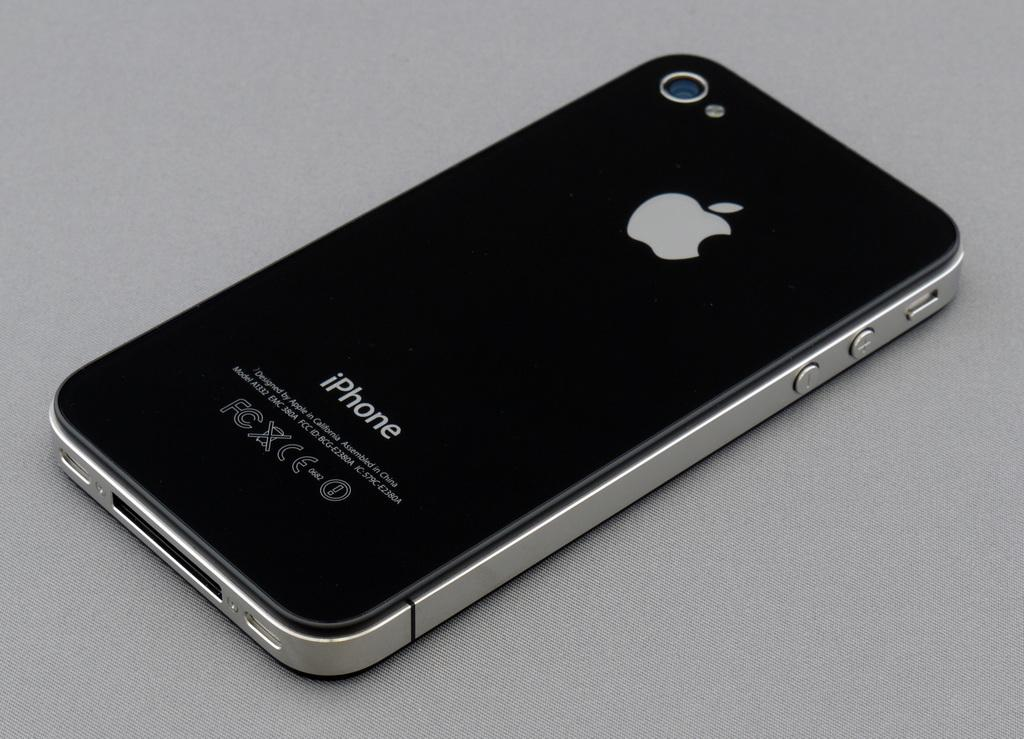<image>
Create a compact narrative representing the image presented. A photo of the back of an Apple iPhone 